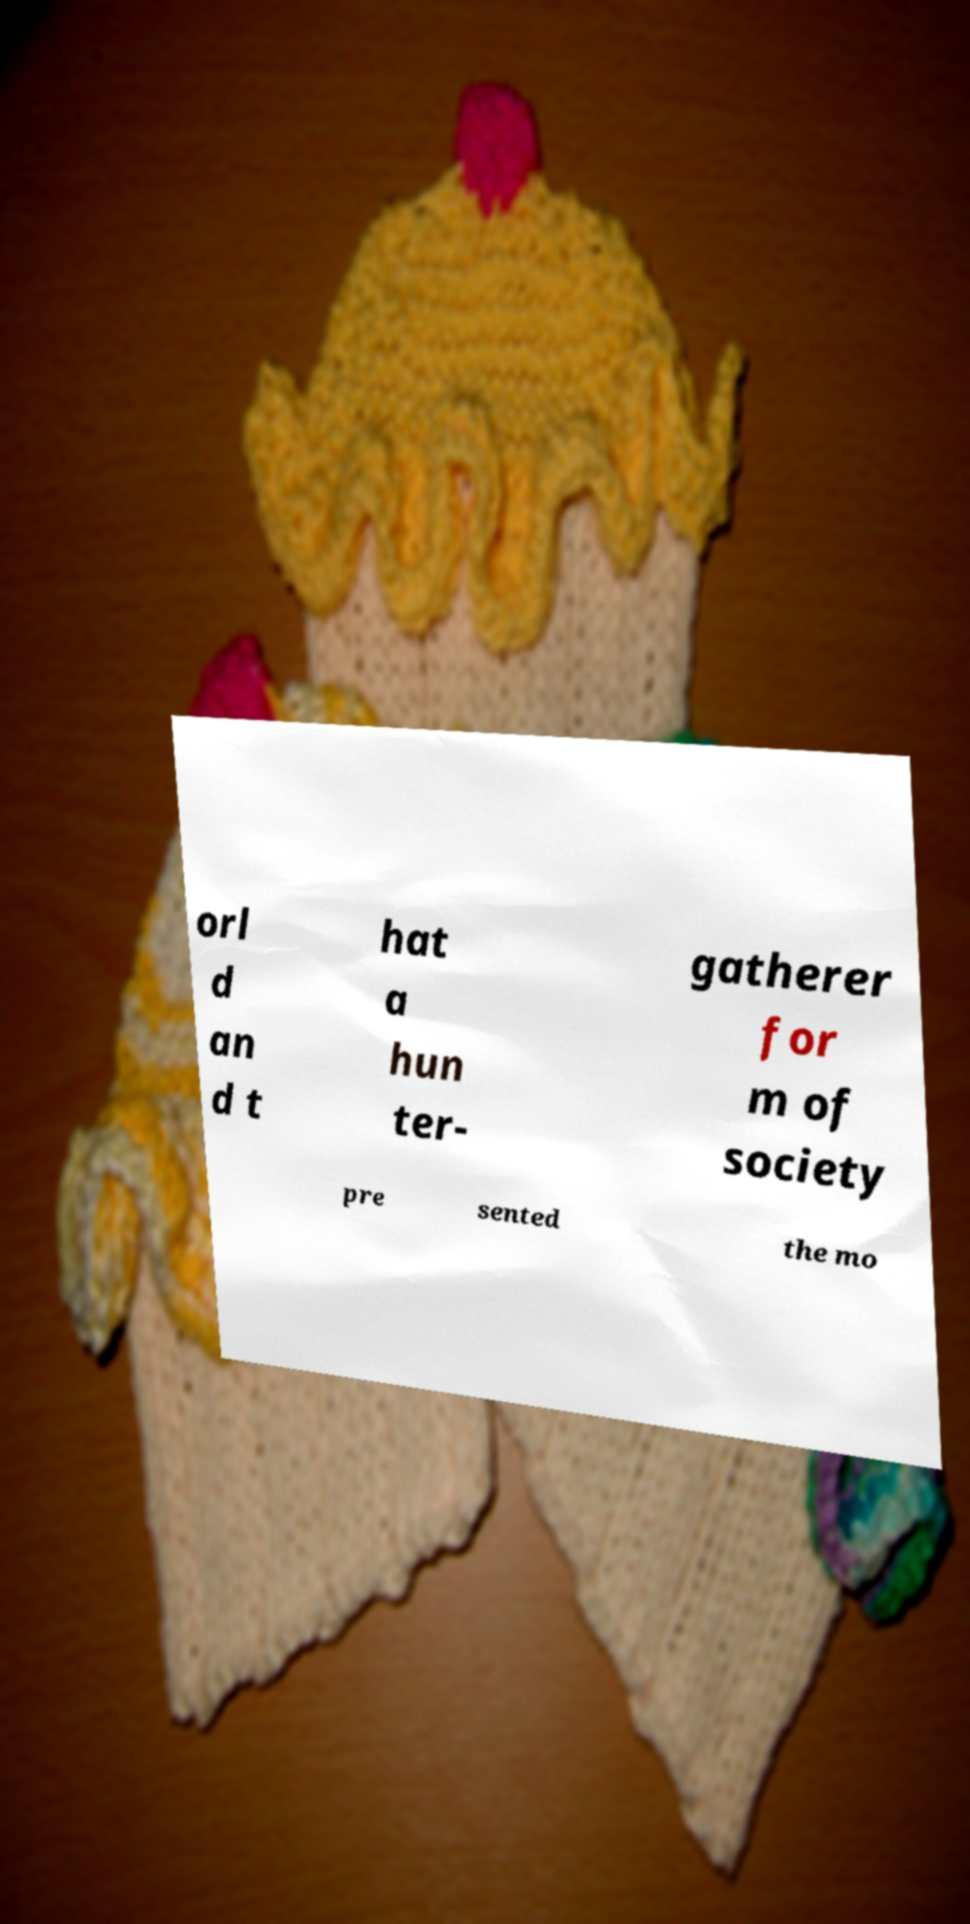What messages or text are displayed in this image? I need them in a readable, typed format. orl d an d t hat a hun ter- gatherer for m of society pre sented the mo 